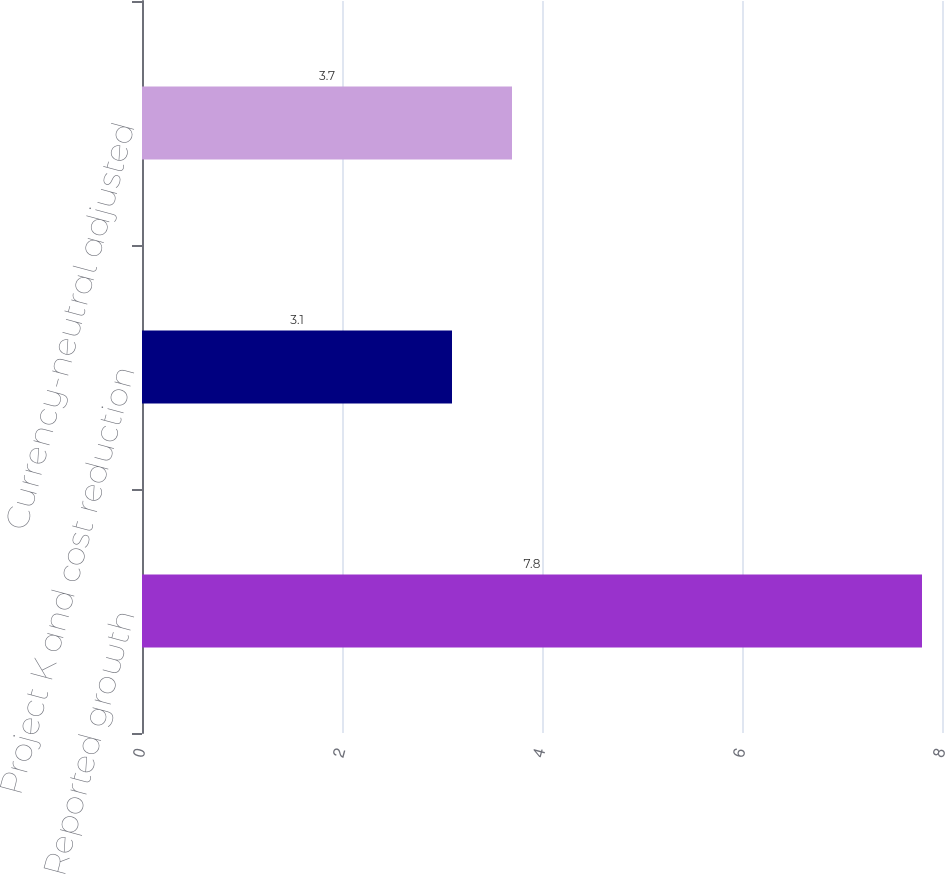<chart> <loc_0><loc_0><loc_500><loc_500><bar_chart><fcel>Reported growth<fcel>Project K and cost reduction<fcel>Currency-neutral adjusted<nl><fcel>7.8<fcel>3.1<fcel>3.7<nl></chart> 